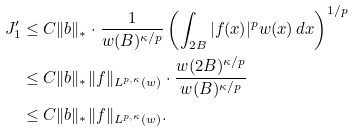<formula> <loc_0><loc_0><loc_500><loc_500>J ^ { \prime } _ { 1 } & \leq C \| b \| _ { * } \cdot \frac { 1 } { w ( B ) ^ { \kappa / p } } \left ( \int _ { 2 B } | f ( x ) | ^ { p } w ( x ) \, d x \right ) ^ { 1 / p } \\ & \leq C \| b \| _ { * } \| f \| _ { L ^ { p , \kappa } ( w ) } \cdot \frac { w ( 2 B ) ^ { \kappa / p } } { w ( B ) ^ { \kappa / p } } \\ & \leq C \| b \| _ { * } \| f \| _ { L ^ { p , \kappa } ( w ) } .</formula> 